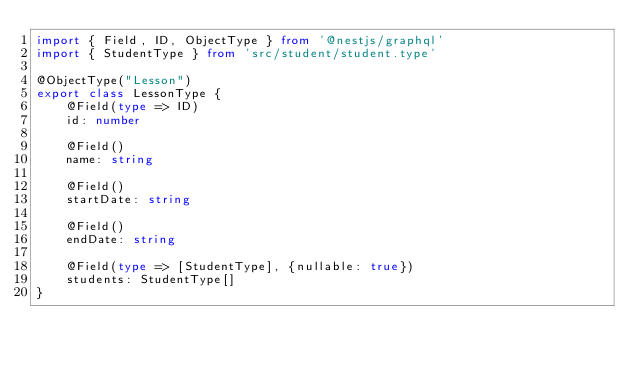<code> <loc_0><loc_0><loc_500><loc_500><_TypeScript_>import { Field, ID, ObjectType } from '@nestjs/graphql'
import { StudentType } from 'src/student/student.type'

@ObjectType("Lesson")
export class LessonType {
    @Field(type => ID)
    id: number

    @Field()
    name: string

    @Field()
    startDate: string

    @Field()
    endDate: string

    @Field(type => [StudentType], {nullable: true})
    students: StudentType[]
}</code> 